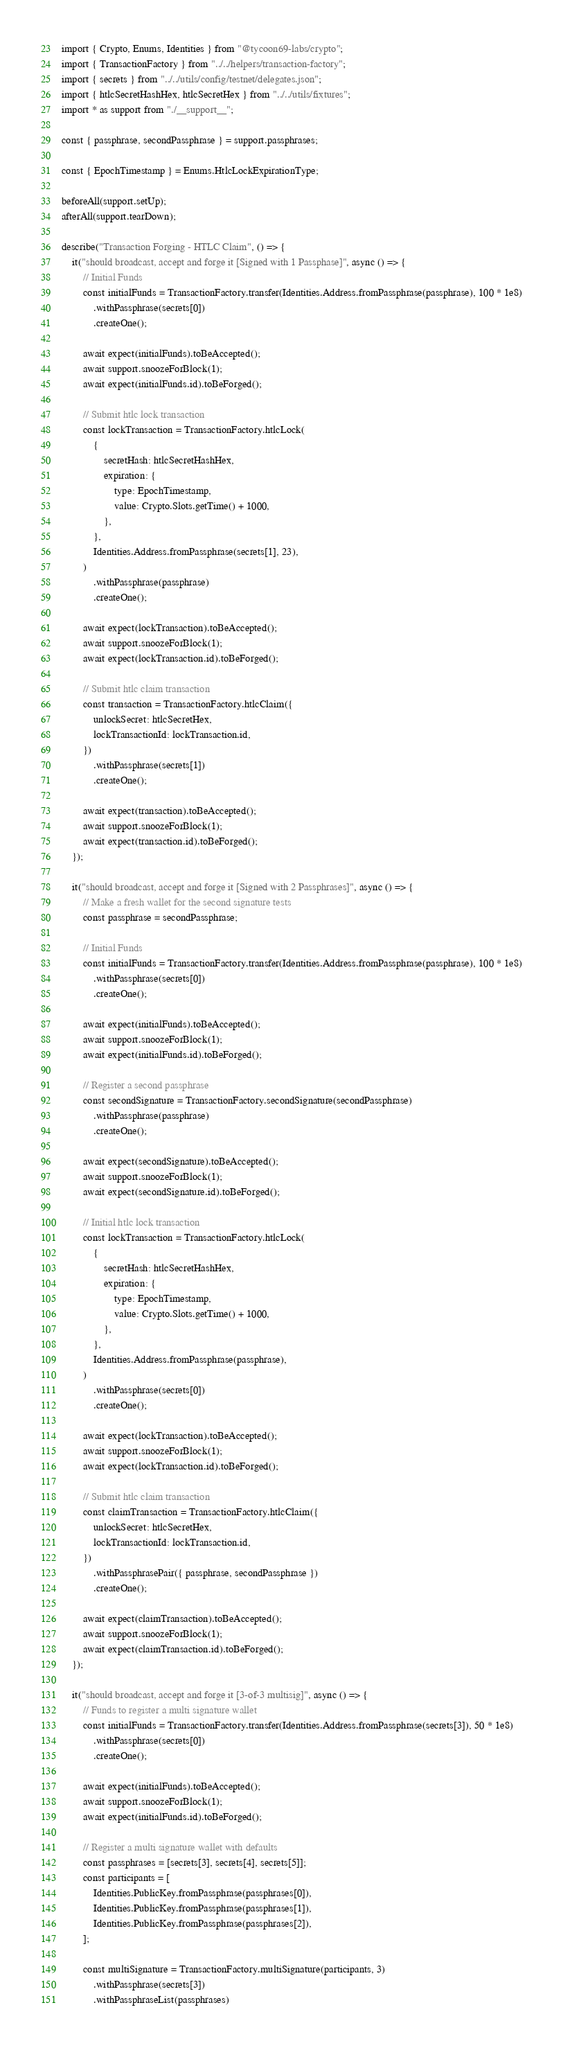<code> <loc_0><loc_0><loc_500><loc_500><_TypeScript_>import { Crypto, Enums, Identities } from "@tycoon69-labs/crypto";
import { TransactionFactory } from "../../helpers/transaction-factory";
import { secrets } from "../../utils/config/testnet/delegates.json";
import { htlcSecretHashHex, htlcSecretHex } from "../../utils/fixtures";
import * as support from "./__support__";

const { passphrase, secondPassphrase } = support.passphrases;

const { EpochTimestamp } = Enums.HtlcLockExpirationType;

beforeAll(support.setUp);
afterAll(support.tearDown);

describe("Transaction Forging - HTLC Claim", () => {
    it("should broadcast, accept and forge it [Signed with 1 Passphase]", async () => {
        // Initial Funds
        const initialFunds = TransactionFactory.transfer(Identities.Address.fromPassphrase(passphrase), 100 * 1e8)
            .withPassphrase(secrets[0])
            .createOne();

        await expect(initialFunds).toBeAccepted();
        await support.snoozeForBlock(1);
        await expect(initialFunds.id).toBeForged();

        // Submit htlc lock transaction
        const lockTransaction = TransactionFactory.htlcLock(
            {
                secretHash: htlcSecretHashHex,
                expiration: {
                    type: EpochTimestamp,
                    value: Crypto.Slots.getTime() + 1000,
                },
            },
            Identities.Address.fromPassphrase(secrets[1], 23),
        )
            .withPassphrase(passphrase)
            .createOne();

        await expect(lockTransaction).toBeAccepted();
        await support.snoozeForBlock(1);
        await expect(lockTransaction.id).toBeForged();

        // Submit htlc claim transaction
        const transaction = TransactionFactory.htlcClaim({
            unlockSecret: htlcSecretHex,
            lockTransactionId: lockTransaction.id,
        })
            .withPassphrase(secrets[1])
            .createOne();

        await expect(transaction).toBeAccepted();
        await support.snoozeForBlock(1);
        await expect(transaction.id).toBeForged();
    });

    it("should broadcast, accept and forge it [Signed with 2 Passphrases]", async () => {
        // Make a fresh wallet for the second signature tests
        const passphrase = secondPassphrase;

        // Initial Funds
        const initialFunds = TransactionFactory.transfer(Identities.Address.fromPassphrase(passphrase), 100 * 1e8)
            .withPassphrase(secrets[0])
            .createOne();

        await expect(initialFunds).toBeAccepted();
        await support.snoozeForBlock(1);
        await expect(initialFunds.id).toBeForged();

        // Register a second passphrase
        const secondSignature = TransactionFactory.secondSignature(secondPassphrase)
            .withPassphrase(passphrase)
            .createOne();

        await expect(secondSignature).toBeAccepted();
        await support.snoozeForBlock(1);
        await expect(secondSignature.id).toBeForged();

        // Initial htlc lock transaction
        const lockTransaction = TransactionFactory.htlcLock(
            {
                secretHash: htlcSecretHashHex,
                expiration: {
                    type: EpochTimestamp,
                    value: Crypto.Slots.getTime() + 1000,
                },
            },
            Identities.Address.fromPassphrase(passphrase),
        )
            .withPassphrase(secrets[0])
            .createOne();

        await expect(lockTransaction).toBeAccepted();
        await support.snoozeForBlock(1);
        await expect(lockTransaction.id).toBeForged();

        // Submit htlc claim transaction
        const claimTransaction = TransactionFactory.htlcClaim({
            unlockSecret: htlcSecretHex,
            lockTransactionId: lockTransaction.id,
        })
            .withPassphrasePair({ passphrase, secondPassphrase })
            .createOne();

        await expect(claimTransaction).toBeAccepted();
        await support.snoozeForBlock(1);
        await expect(claimTransaction.id).toBeForged();
    });

    it("should broadcast, accept and forge it [3-of-3 multisig]", async () => {
        // Funds to register a multi signature wallet
        const initialFunds = TransactionFactory.transfer(Identities.Address.fromPassphrase(secrets[3]), 50 * 1e8)
            .withPassphrase(secrets[0])
            .createOne();

        await expect(initialFunds).toBeAccepted();
        await support.snoozeForBlock(1);
        await expect(initialFunds.id).toBeForged();

        // Register a multi signature wallet with defaults
        const passphrases = [secrets[3], secrets[4], secrets[5]];
        const participants = [
            Identities.PublicKey.fromPassphrase(passphrases[0]),
            Identities.PublicKey.fromPassphrase(passphrases[1]),
            Identities.PublicKey.fromPassphrase(passphrases[2]),
        ];

        const multiSignature = TransactionFactory.multiSignature(participants, 3)
            .withPassphrase(secrets[3])
            .withPassphraseList(passphrases)</code> 